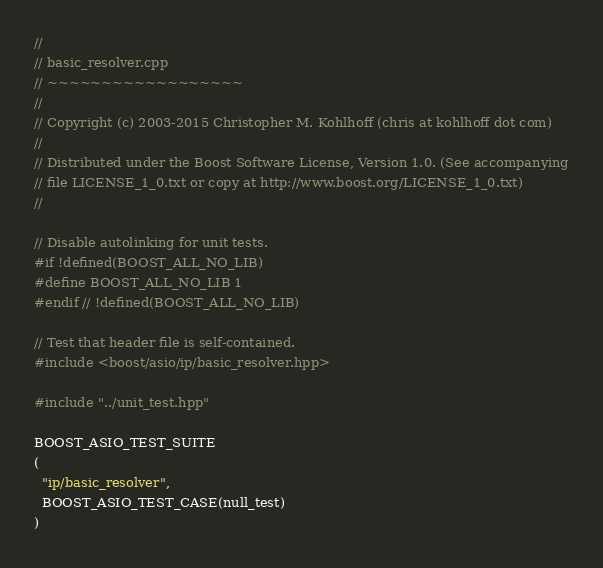Convert code to text. <code><loc_0><loc_0><loc_500><loc_500><_C++_>//
// basic_resolver.cpp
// ~~~~~~~~~~~~~~~~~~
//
// Copyright (c) 2003-2015 Christopher M. Kohlhoff (chris at kohlhoff dot com)
//
// Distributed under the Boost Software License, Version 1.0. (See accompanying
// file LICENSE_1_0.txt or copy at http://www.boost.org/LICENSE_1_0.txt)
//

// Disable autolinking for unit tests.
#if !defined(BOOST_ALL_NO_LIB)
#define BOOST_ALL_NO_LIB 1
#endif // !defined(BOOST_ALL_NO_LIB)

// Test that header file is self-contained.
#include <boost/asio/ip/basic_resolver.hpp>

#include "../unit_test.hpp"

BOOST_ASIO_TEST_SUITE
(
  "ip/basic_resolver",
  BOOST_ASIO_TEST_CASE(null_test)
)
</code> 